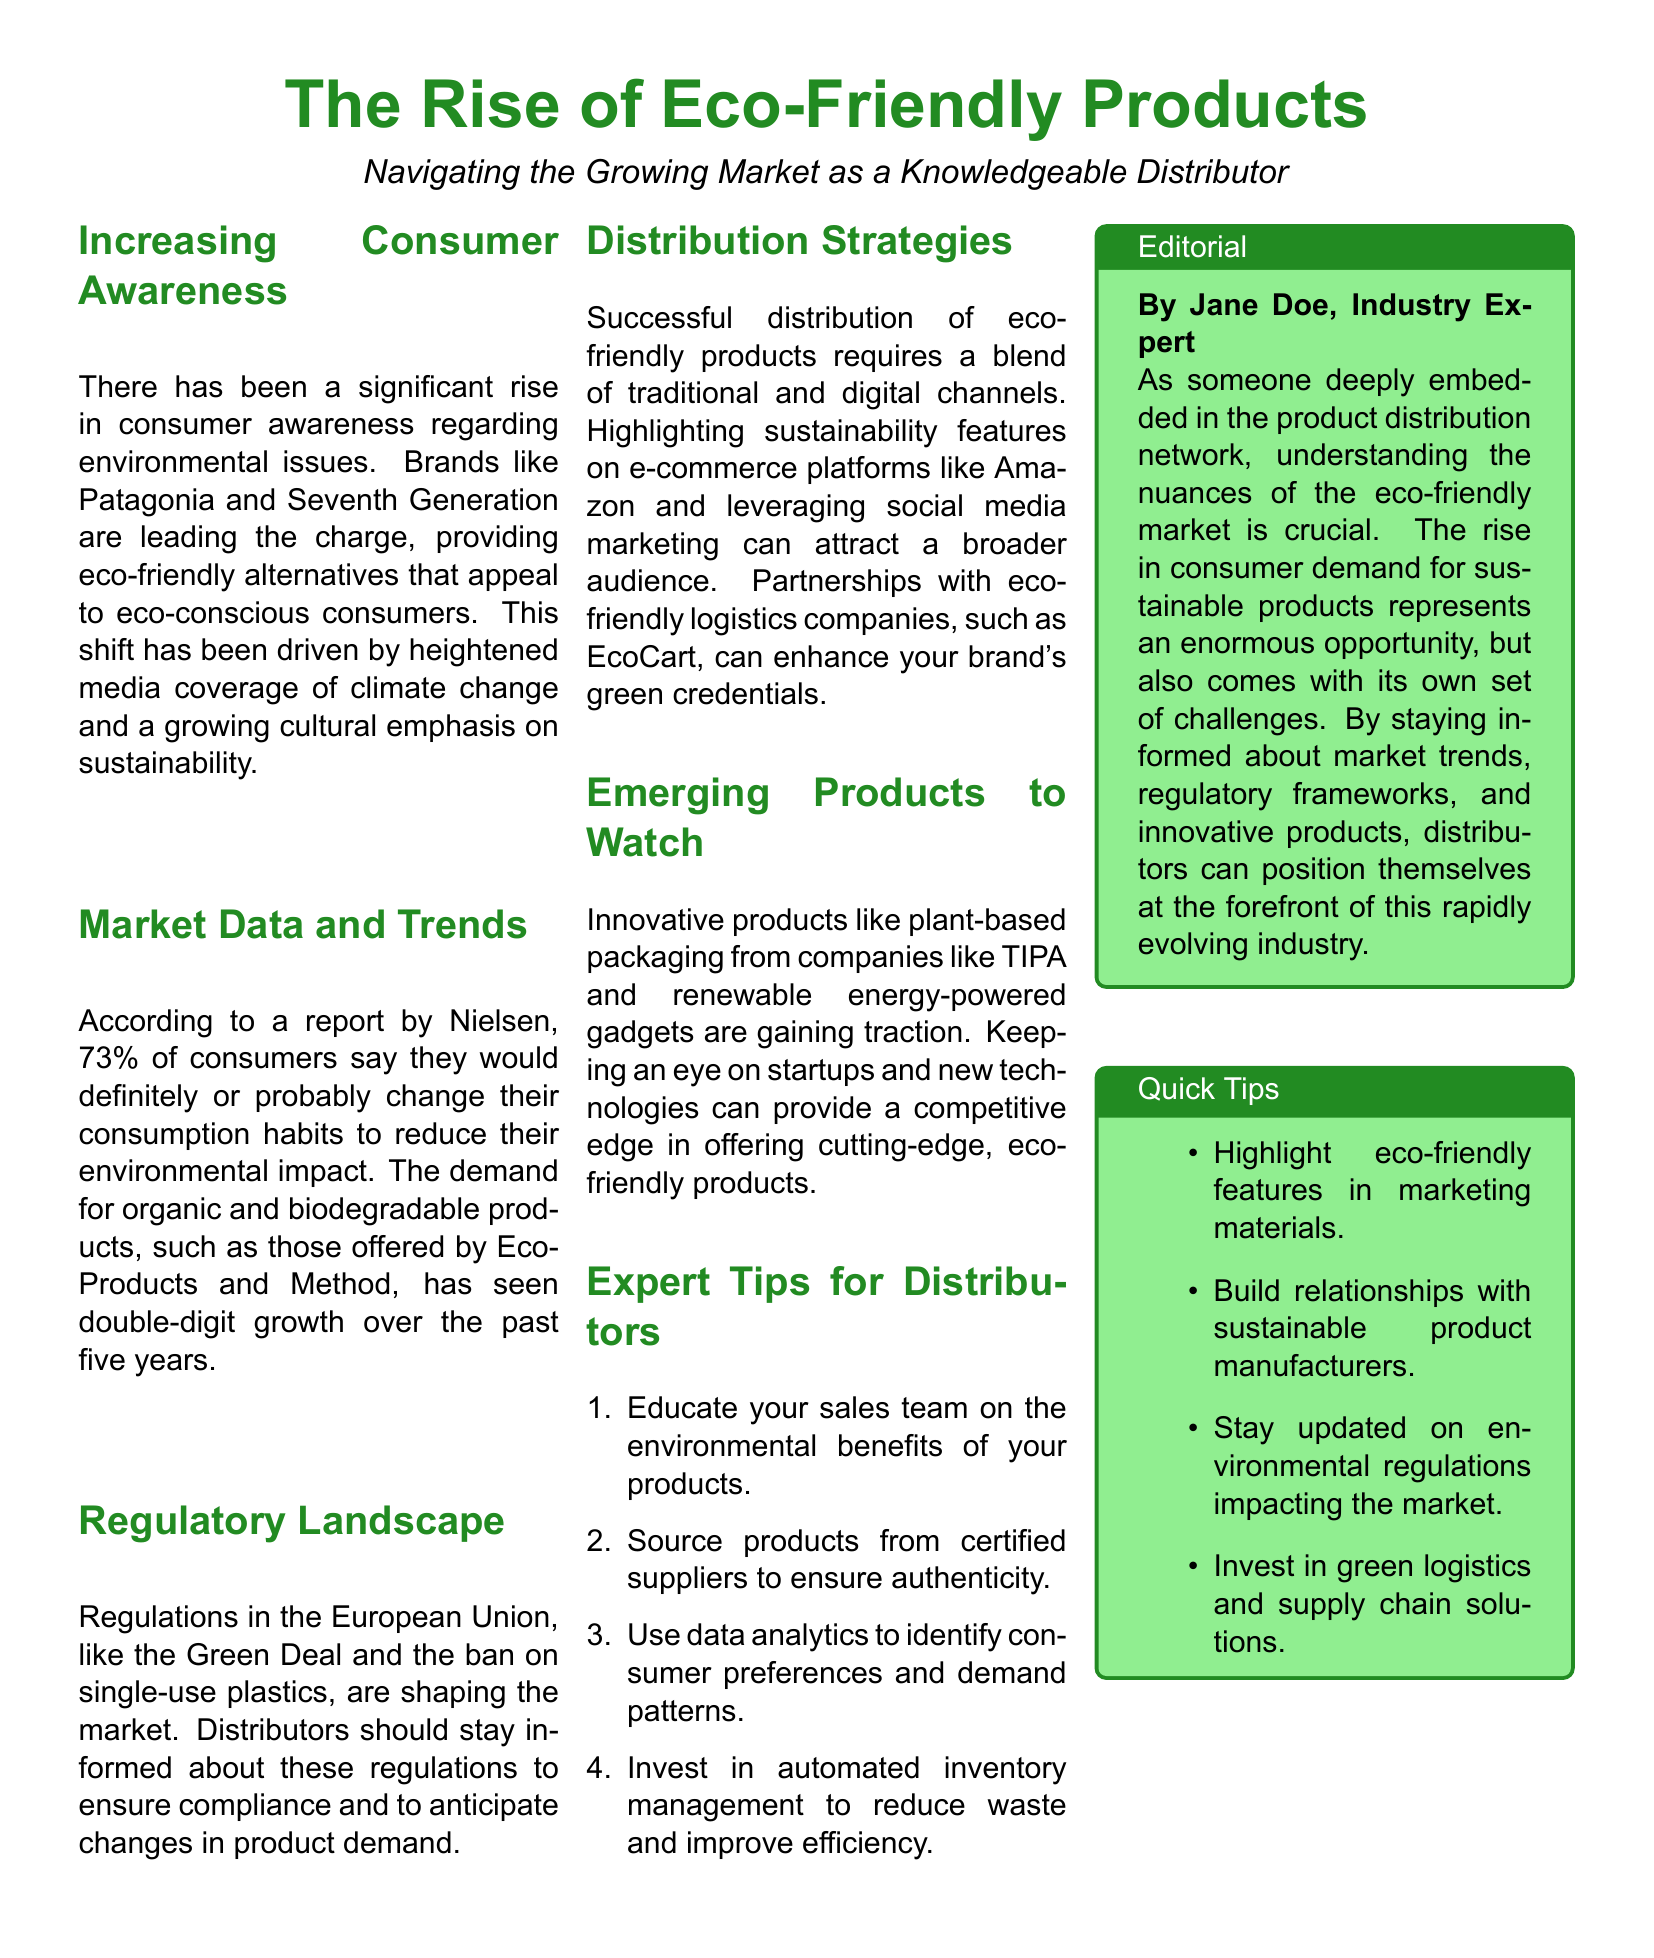What is the main focus of the document? The document discusses the rise of eco-friendly products and the related trends in demand and distribution strategies.
Answer: Eco-Friendly Products Who are leading brands mentioned in the document? The document indicates that Patagonia and Seventh Generation are prominent brands in the eco-friendly market.
Answer: Patagonia and Seventh Generation What percentage of consumers would change their consumption habits? According to the document, 73% of consumers say they would definitely or probably change their consumption habits to reduce environmental impact.
Answer: 73% What is one recommended distribution strategy for eco-friendly products? The document suggests highlighting sustainability features on e-commerce platforms as a successful distribution strategy.
Answer: Highlighting sustainability features What type of products are gaining traction according to the document? The document notes that plant-based packaging and renewable energy-powered gadgets are emerging products to watch.
Answer: Plant-based packaging and renewable energy-powered gadgets What regulatory framework is mentioned in the document? The document refers to the European Union's Green Deal and the ban on single-use plastics as important regulations.
Answer: Green Deal and the ban on single-use plastics Which company is mentioned for eco-friendly logistics? EcoCart is identified in the document as an eco-friendly logistics company that can enhance a brand's green credentials.
Answer: EcoCart What does the editorial section emphasize for distributors? The editorial emphasizes the importance of understanding market trends and regulatory frameworks for distributors of eco-friendly products.
Answer: Understanding market trends and regulatory frameworks What is one quick tip for distributors mentioned in the document? The document contains several quick tips, one of which is to build relationships with sustainable product manufacturers.
Answer: Build relationships with sustainable product manufacturers 